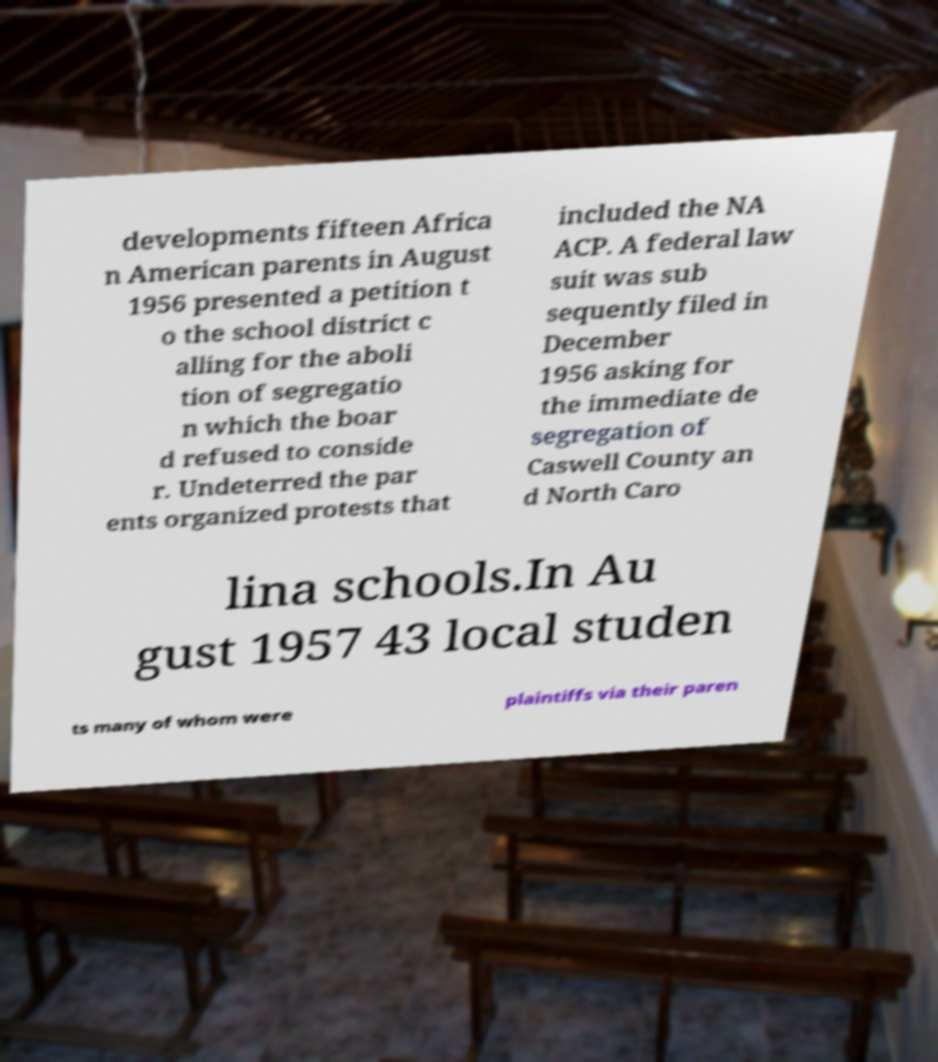There's text embedded in this image that I need extracted. Can you transcribe it verbatim? developments fifteen Africa n American parents in August 1956 presented a petition t o the school district c alling for the aboli tion of segregatio n which the boar d refused to conside r. Undeterred the par ents organized protests that included the NA ACP. A federal law suit was sub sequently filed in December 1956 asking for the immediate de segregation of Caswell County an d North Caro lina schools.In Au gust 1957 43 local studen ts many of whom were plaintiffs via their paren 